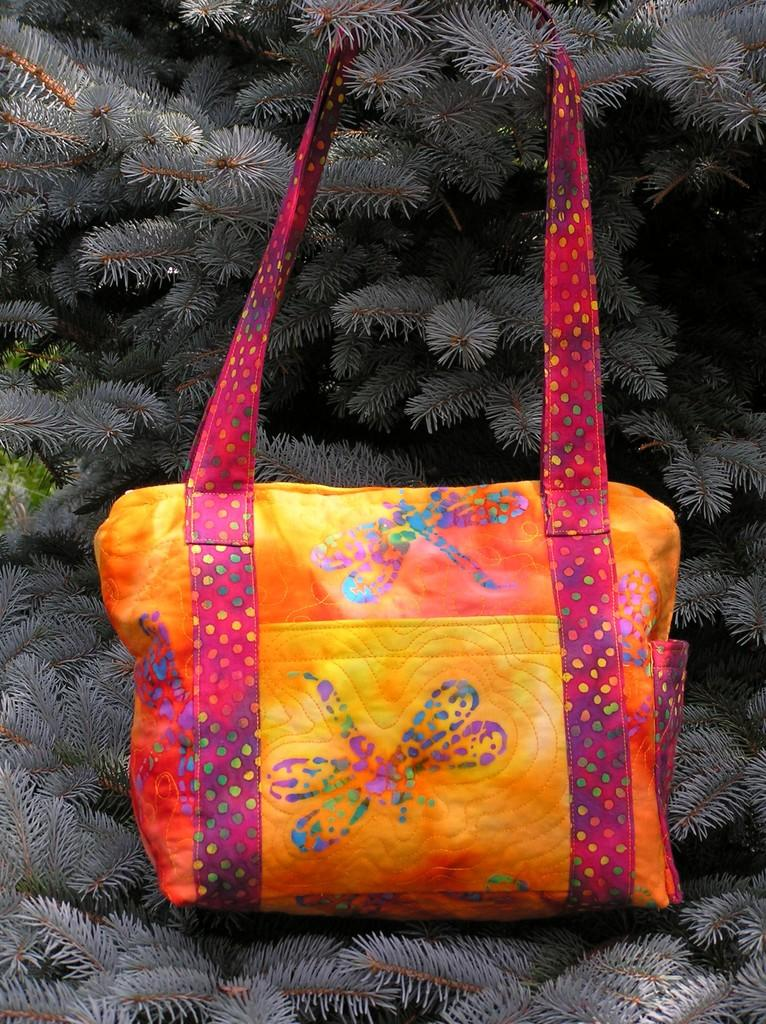What is the main subject of the image? The main subject of the image is a beautiful handbag. How is the handbag positioned in the image? The handbag is attached to a plant. What type of bone can be seen inside the handbag in the image? There is no bone visible inside the handbag in the image. How many stitches can be seen on the handbag in the image? The image does not provide enough detail to count the stitches on the handbag. What type of meat is being stored in the handbag in the image? There is no meat present in the image; it features a beautiful handbag attached to a plant. 